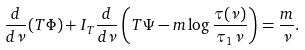<formula> <loc_0><loc_0><loc_500><loc_500>\frac { d } { d \nu } ( T \Phi ) + I _ { T } \frac { d } { d \nu } \left ( T \Psi - m \log \frac { \tau ( \nu ) } { \tau _ { 1 } \nu } \right ) = \frac { m } { \nu } .</formula> 